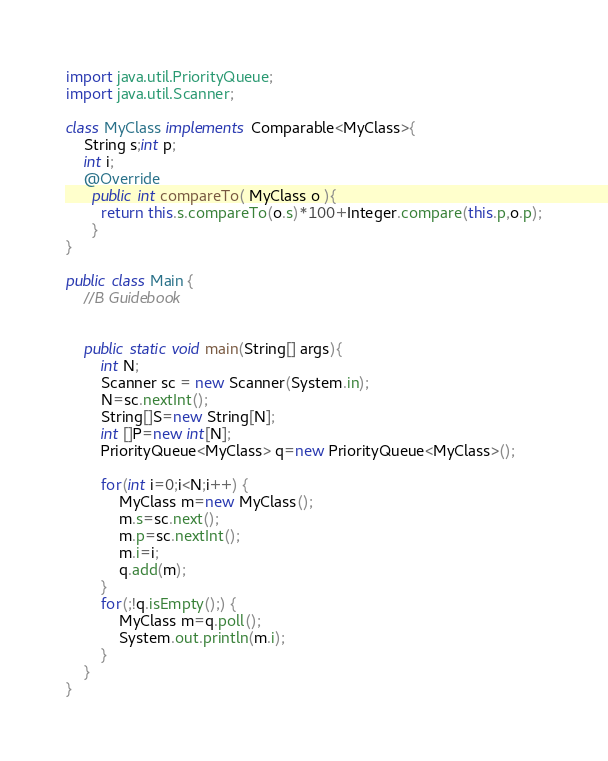<code> <loc_0><loc_0><loc_500><loc_500><_Java_>import java.util.PriorityQueue;
import java.util.Scanner;

class MyClass implements Comparable<MyClass>{
	String s;int p;
	int i;
	@Override
	  public int compareTo( MyClass o ){
	    return this.s.compareTo(o.s)*100+Integer.compare(this.p,o.p);
	  }
}

public class Main {
	//B Guidebook


	public static void main(String[] args){
		int N;
		Scanner sc = new Scanner(System.in);
		N=sc.nextInt();
		String[]S=new String[N];
		int []P=new int[N];
		PriorityQueue<MyClass> q=new PriorityQueue<MyClass>();

		for(int i=0;i<N;i++) {
			MyClass m=new MyClass();
			m.s=sc.next();
			m.p=sc.nextInt();
			m.i=i;
			q.add(m);
		}
		for(;!q.isEmpty();) {
			MyClass m=q.poll();
			System.out.println(m.i);
		}
	}
}</code> 